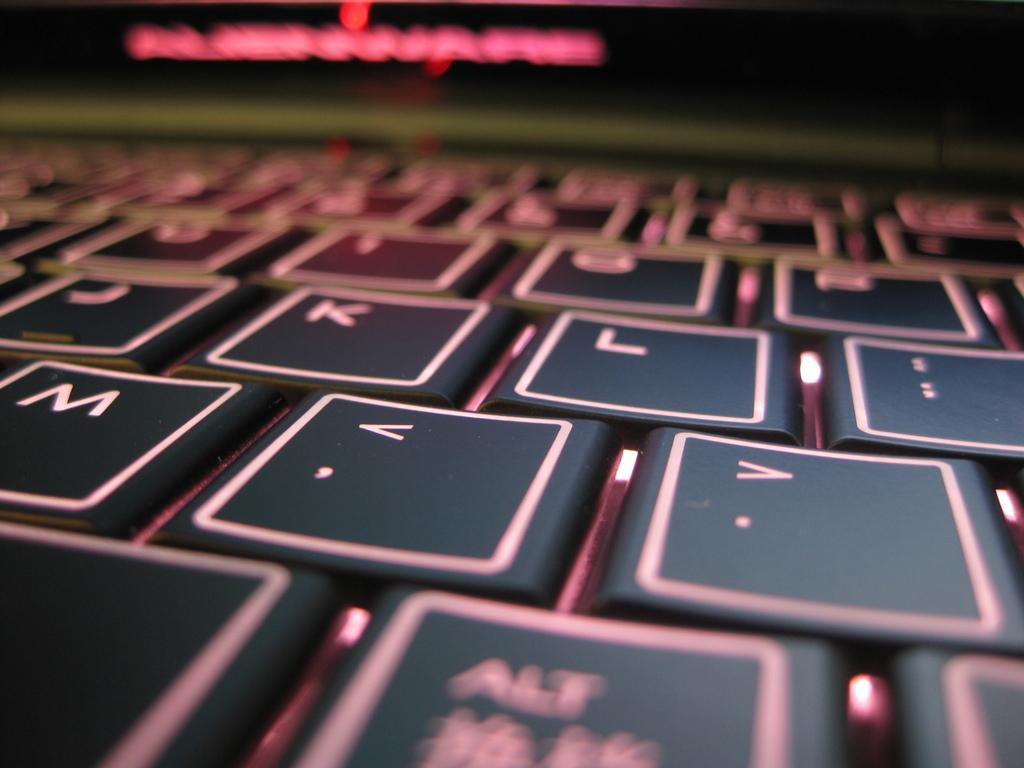Please provide a concise description of this image. In the picture we can see a keyboard with keys on it which are black in color and far away from it we can see a red colored light. 